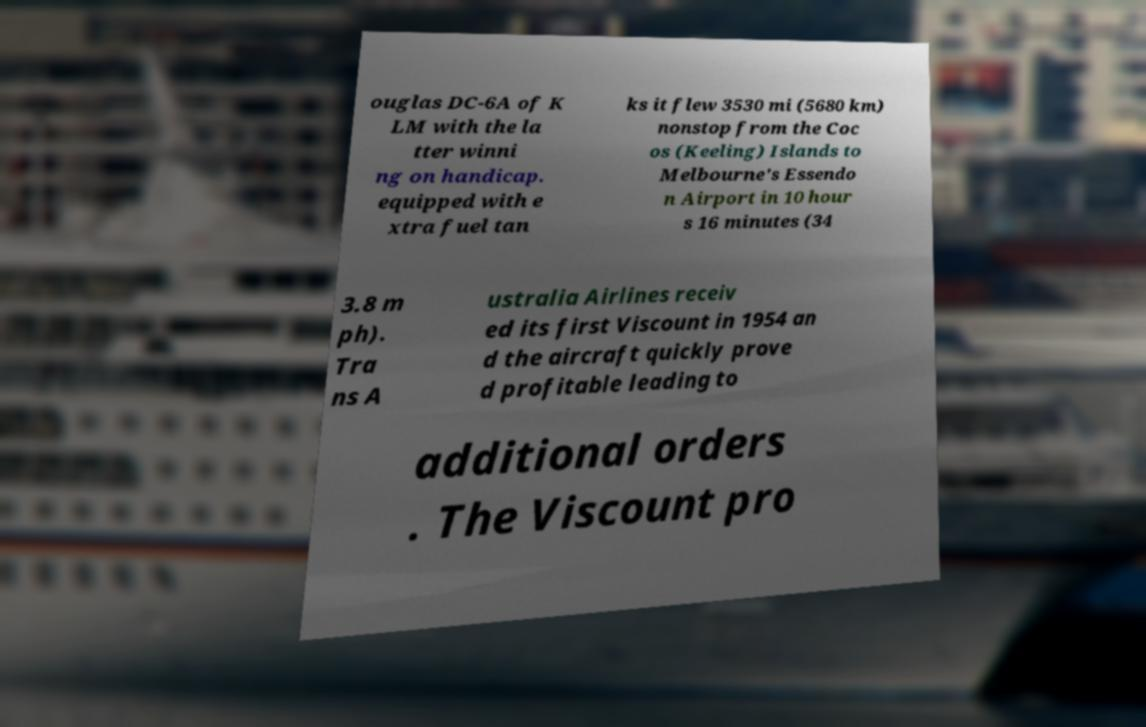I need the written content from this picture converted into text. Can you do that? ouglas DC-6A of K LM with the la tter winni ng on handicap. equipped with e xtra fuel tan ks it flew 3530 mi (5680 km) nonstop from the Coc os (Keeling) Islands to Melbourne's Essendo n Airport in 10 hour s 16 minutes (34 3.8 m ph). Tra ns A ustralia Airlines receiv ed its first Viscount in 1954 an d the aircraft quickly prove d profitable leading to additional orders . The Viscount pro 